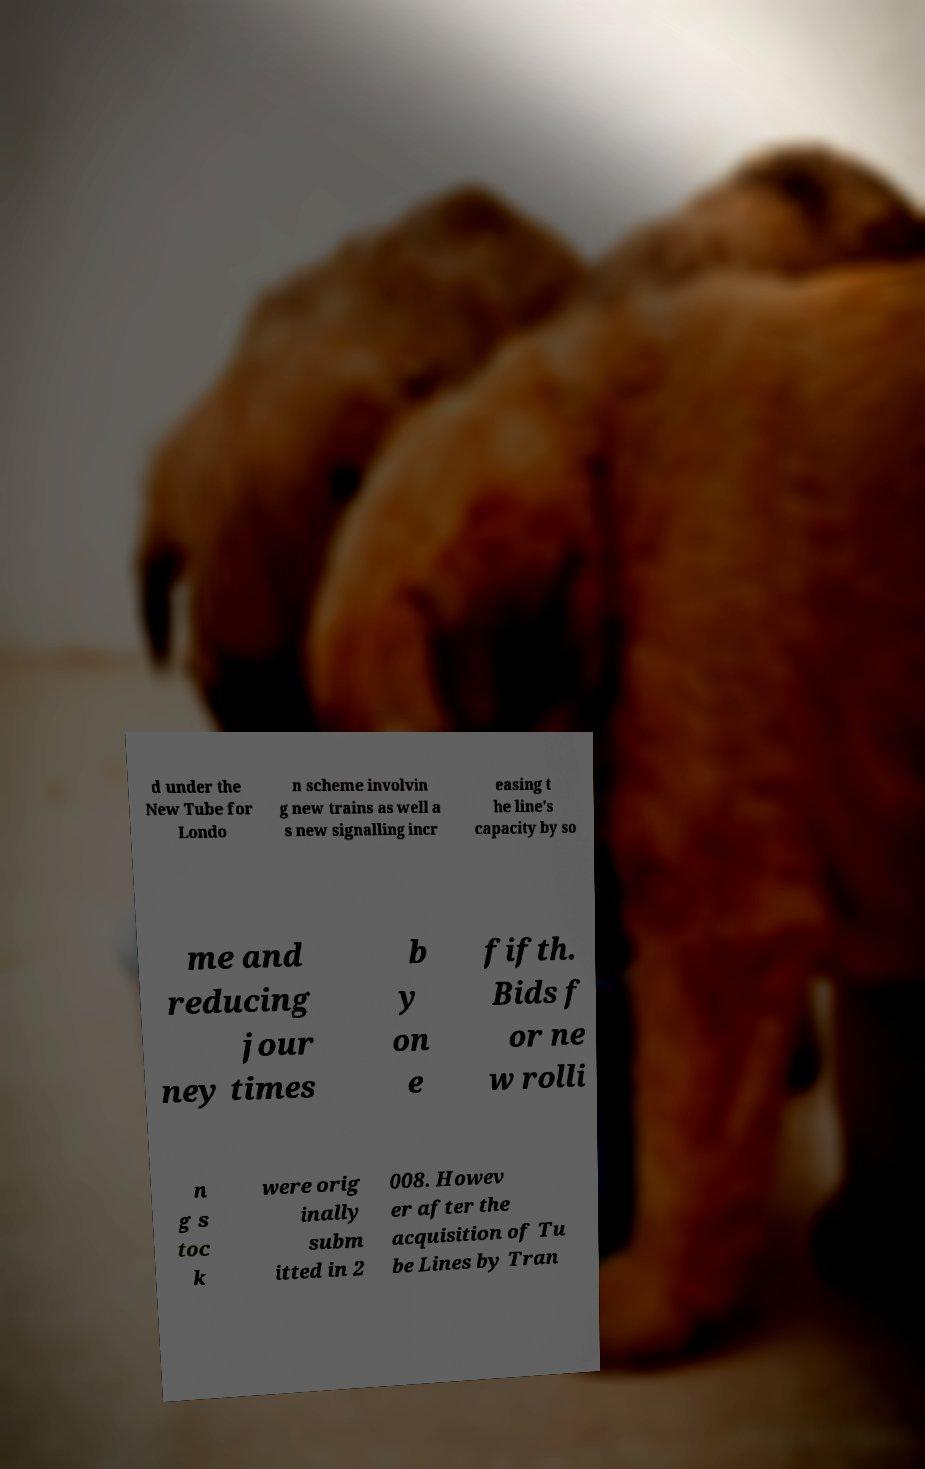Could you assist in decoding the text presented in this image and type it out clearly? d under the New Tube for Londo n scheme involvin g new trains as well a s new signalling incr easing t he line's capacity by so me and reducing jour ney times b y on e fifth. Bids f or ne w rolli n g s toc k were orig inally subm itted in 2 008. Howev er after the acquisition of Tu be Lines by Tran 